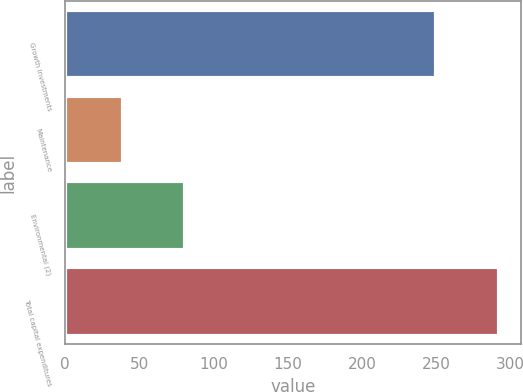Convert chart to OTSL. <chart><loc_0><loc_0><loc_500><loc_500><bar_chart><fcel>Growth Investments<fcel>Maintenance<fcel>Environmental (2)<fcel>Total capital expenditures<nl><fcel>250<fcel>39<fcel>81<fcel>292<nl></chart> 